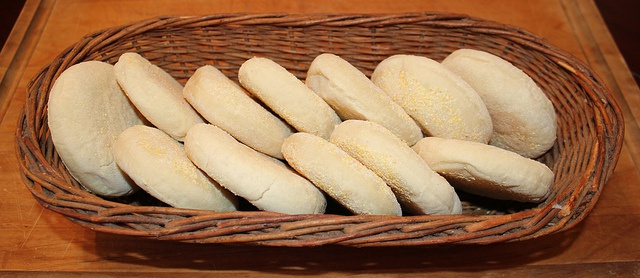Describe the objects in this image and their specific colors. I can see a dining table in brown, tan, maroon, and black tones in this image. 